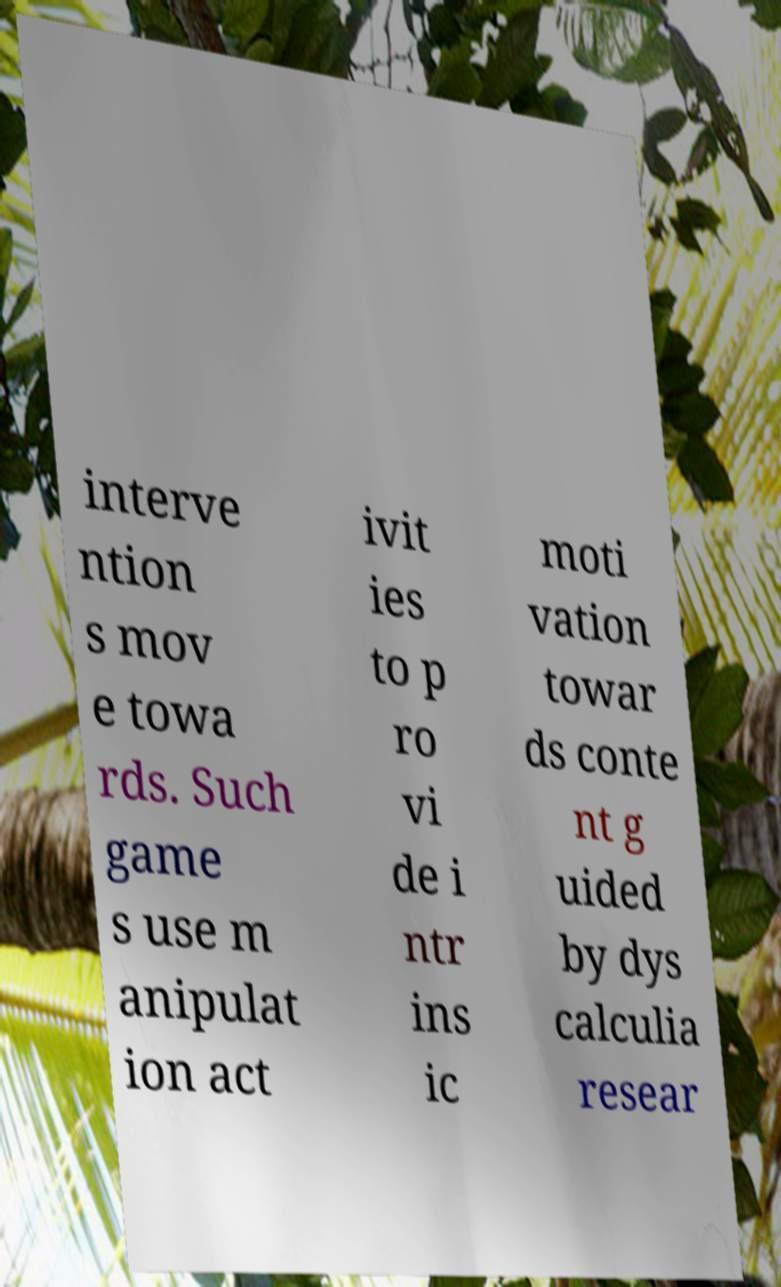Can you read and provide the text displayed in the image?This photo seems to have some interesting text. Can you extract and type it out for me? interve ntion s mov e towa rds. Such game s use m anipulat ion act ivit ies to p ro vi de i ntr ins ic moti vation towar ds conte nt g uided by dys calculia resear 